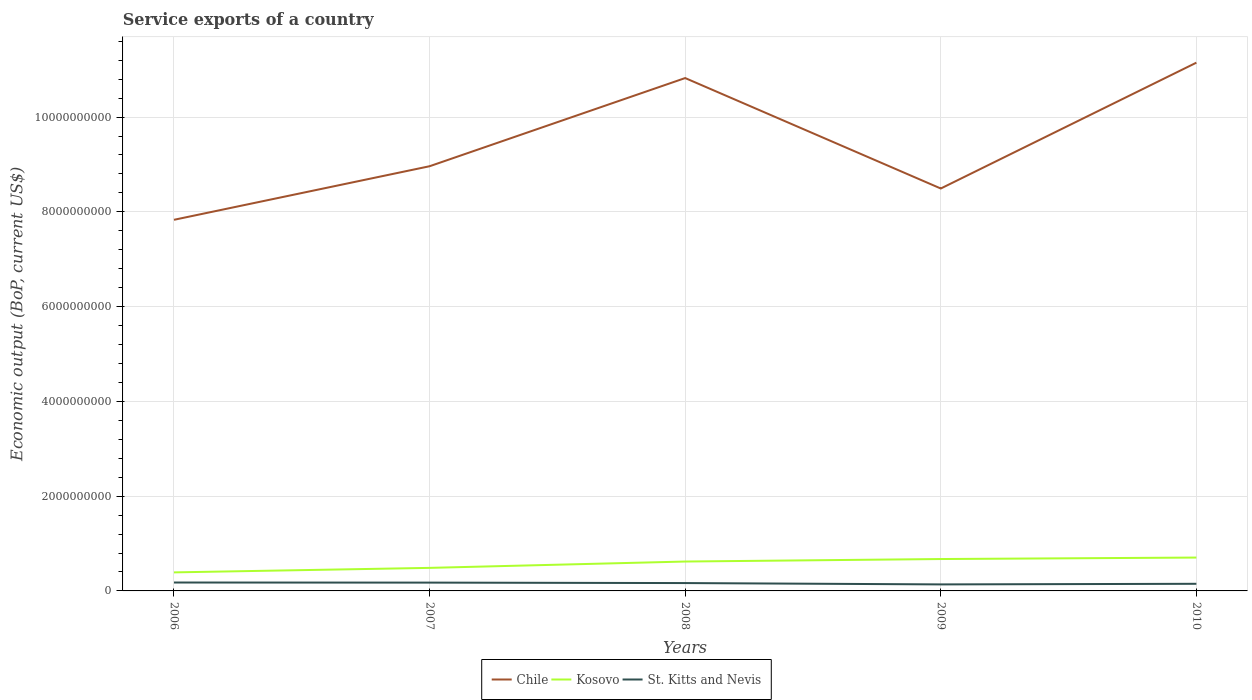Does the line corresponding to St. Kitts and Nevis intersect with the line corresponding to Chile?
Ensure brevity in your answer.  No. Is the number of lines equal to the number of legend labels?
Your answer should be compact. Yes. Across all years, what is the maximum service exports in St. Kitts and Nevis?
Make the answer very short. 1.37e+08. What is the total service exports in Kosovo in the graph?
Offer a terse response. -1.34e+08. What is the difference between the highest and the second highest service exports in Kosovo?
Keep it short and to the point. 3.13e+08. What is the difference between two consecutive major ticks on the Y-axis?
Your answer should be compact. 2.00e+09. Does the graph contain any zero values?
Ensure brevity in your answer.  No. Does the graph contain grids?
Offer a terse response. Yes. Where does the legend appear in the graph?
Provide a short and direct response. Bottom center. What is the title of the graph?
Provide a short and direct response. Service exports of a country. Does "Sweden" appear as one of the legend labels in the graph?
Your response must be concise. No. What is the label or title of the Y-axis?
Offer a terse response. Economic output (BoP, current US$). What is the Economic output (BoP, current US$) in Chile in 2006?
Make the answer very short. 7.83e+09. What is the Economic output (BoP, current US$) of Kosovo in 2006?
Offer a very short reply. 3.91e+08. What is the Economic output (BoP, current US$) in St. Kitts and Nevis in 2006?
Your response must be concise. 1.77e+08. What is the Economic output (BoP, current US$) of Chile in 2007?
Provide a succinct answer. 8.96e+09. What is the Economic output (BoP, current US$) in Kosovo in 2007?
Provide a succinct answer. 4.86e+08. What is the Economic output (BoP, current US$) of St. Kitts and Nevis in 2007?
Ensure brevity in your answer.  1.75e+08. What is the Economic output (BoP, current US$) of Chile in 2008?
Offer a terse response. 1.08e+1. What is the Economic output (BoP, current US$) in Kosovo in 2008?
Your response must be concise. 6.20e+08. What is the Economic output (BoP, current US$) in St. Kitts and Nevis in 2008?
Offer a very short reply. 1.66e+08. What is the Economic output (BoP, current US$) of Chile in 2009?
Provide a succinct answer. 8.49e+09. What is the Economic output (BoP, current US$) in Kosovo in 2009?
Your response must be concise. 6.73e+08. What is the Economic output (BoP, current US$) in St. Kitts and Nevis in 2009?
Make the answer very short. 1.37e+08. What is the Economic output (BoP, current US$) in Chile in 2010?
Your answer should be compact. 1.11e+1. What is the Economic output (BoP, current US$) of Kosovo in 2010?
Provide a short and direct response. 7.04e+08. What is the Economic output (BoP, current US$) of St. Kitts and Nevis in 2010?
Your answer should be compact. 1.50e+08. Across all years, what is the maximum Economic output (BoP, current US$) in Chile?
Give a very brief answer. 1.11e+1. Across all years, what is the maximum Economic output (BoP, current US$) of Kosovo?
Offer a very short reply. 7.04e+08. Across all years, what is the maximum Economic output (BoP, current US$) in St. Kitts and Nevis?
Your answer should be compact. 1.77e+08. Across all years, what is the minimum Economic output (BoP, current US$) in Chile?
Ensure brevity in your answer.  7.83e+09. Across all years, what is the minimum Economic output (BoP, current US$) of Kosovo?
Provide a succinct answer. 3.91e+08. Across all years, what is the minimum Economic output (BoP, current US$) in St. Kitts and Nevis?
Your answer should be very brief. 1.37e+08. What is the total Economic output (BoP, current US$) in Chile in the graph?
Keep it short and to the point. 4.73e+1. What is the total Economic output (BoP, current US$) of Kosovo in the graph?
Provide a succinct answer. 2.87e+09. What is the total Economic output (BoP, current US$) in St. Kitts and Nevis in the graph?
Your answer should be very brief. 8.06e+08. What is the difference between the Economic output (BoP, current US$) of Chile in 2006 and that in 2007?
Make the answer very short. -1.13e+09. What is the difference between the Economic output (BoP, current US$) of Kosovo in 2006 and that in 2007?
Your answer should be compact. -9.52e+07. What is the difference between the Economic output (BoP, current US$) in St. Kitts and Nevis in 2006 and that in 2007?
Your answer should be compact. 2.00e+06. What is the difference between the Economic output (BoP, current US$) of Chile in 2006 and that in 2008?
Provide a succinct answer. -2.99e+09. What is the difference between the Economic output (BoP, current US$) of Kosovo in 2006 and that in 2008?
Provide a succinct answer. -2.29e+08. What is the difference between the Economic output (BoP, current US$) of St. Kitts and Nevis in 2006 and that in 2008?
Your response must be concise. 1.17e+07. What is the difference between the Economic output (BoP, current US$) of Chile in 2006 and that in 2009?
Your answer should be compact. -6.61e+08. What is the difference between the Economic output (BoP, current US$) in Kosovo in 2006 and that in 2009?
Your answer should be very brief. -2.82e+08. What is the difference between the Economic output (BoP, current US$) in St. Kitts and Nevis in 2006 and that in 2009?
Offer a terse response. 4.02e+07. What is the difference between the Economic output (BoP, current US$) in Chile in 2006 and that in 2010?
Offer a very short reply. -3.32e+09. What is the difference between the Economic output (BoP, current US$) of Kosovo in 2006 and that in 2010?
Provide a succinct answer. -3.13e+08. What is the difference between the Economic output (BoP, current US$) in St. Kitts and Nevis in 2006 and that in 2010?
Ensure brevity in your answer.  2.73e+07. What is the difference between the Economic output (BoP, current US$) in Chile in 2007 and that in 2008?
Provide a succinct answer. -1.86e+09. What is the difference between the Economic output (BoP, current US$) in Kosovo in 2007 and that in 2008?
Ensure brevity in your answer.  -1.34e+08. What is the difference between the Economic output (BoP, current US$) in St. Kitts and Nevis in 2007 and that in 2008?
Your answer should be compact. 9.67e+06. What is the difference between the Economic output (BoP, current US$) in Chile in 2007 and that in 2009?
Your answer should be very brief. 4.70e+08. What is the difference between the Economic output (BoP, current US$) of Kosovo in 2007 and that in 2009?
Keep it short and to the point. -1.87e+08. What is the difference between the Economic output (BoP, current US$) of St. Kitts and Nevis in 2007 and that in 2009?
Offer a very short reply. 3.82e+07. What is the difference between the Economic output (BoP, current US$) of Chile in 2007 and that in 2010?
Ensure brevity in your answer.  -2.19e+09. What is the difference between the Economic output (BoP, current US$) of Kosovo in 2007 and that in 2010?
Provide a short and direct response. -2.17e+08. What is the difference between the Economic output (BoP, current US$) of St. Kitts and Nevis in 2007 and that in 2010?
Ensure brevity in your answer.  2.53e+07. What is the difference between the Economic output (BoP, current US$) of Chile in 2008 and that in 2009?
Make the answer very short. 2.33e+09. What is the difference between the Economic output (BoP, current US$) of Kosovo in 2008 and that in 2009?
Make the answer very short. -5.27e+07. What is the difference between the Economic output (BoP, current US$) of St. Kitts and Nevis in 2008 and that in 2009?
Your answer should be compact. 2.85e+07. What is the difference between the Economic output (BoP, current US$) in Chile in 2008 and that in 2010?
Give a very brief answer. -3.25e+08. What is the difference between the Economic output (BoP, current US$) of Kosovo in 2008 and that in 2010?
Your answer should be very brief. -8.37e+07. What is the difference between the Economic output (BoP, current US$) in St. Kitts and Nevis in 2008 and that in 2010?
Ensure brevity in your answer.  1.56e+07. What is the difference between the Economic output (BoP, current US$) of Chile in 2009 and that in 2010?
Your answer should be very brief. -2.66e+09. What is the difference between the Economic output (BoP, current US$) of Kosovo in 2009 and that in 2010?
Your response must be concise. -3.09e+07. What is the difference between the Economic output (BoP, current US$) of St. Kitts and Nevis in 2009 and that in 2010?
Give a very brief answer. -1.29e+07. What is the difference between the Economic output (BoP, current US$) of Chile in 2006 and the Economic output (BoP, current US$) of Kosovo in 2007?
Ensure brevity in your answer.  7.35e+09. What is the difference between the Economic output (BoP, current US$) in Chile in 2006 and the Economic output (BoP, current US$) in St. Kitts and Nevis in 2007?
Your answer should be compact. 7.66e+09. What is the difference between the Economic output (BoP, current US$) in Kosovo in 2006 and the Economic output (BoP, current US$) in St. Kitts and Nevis in 2007?
Keep it short and to the point. 2.16e+08. What is the difference between the Economic output (BoP, current US$) in Chile in 2006 and the Economic output (BoP, current US$) in Kosovo in 2008?
Offer a very short reply. 7.21e+09. What is the difference between the Economic output (BoP, current US$) in Chile in 2006 and the Economic output (BoP, current US$) in St. Kitts and Nevis in 2008?
Provide a succinct answer. 7.67e+09. What is the difference between the Economic output (BoP, current US$) in Kosovo in 2006 and the Economic output (BoP, current US$) in St. Kitts and Nevis in 2008?
Provide a succinct answer. 2.25e+08. What is the difference between the Economic output (BoP, current US$) of Chile in 2006 and the Economic output (BoP, current US$) of Kosovo in 2009?
Offer a very short reply. 7.16e+09. What is the difference between the Economic output (BoP, current US$) in Chile in 2006 and the Economic output (BoP, current US$) in St. Kitts and Nevis in 2009?
Make the answer very short. 7.69e+09. What is the difference between the Economic output (BoP, current US$) of Kosovo in 2006 and the Economic output (BoP, current US$) of St. Kitts and Nevis in 2009?
Provide a short and direct response. 2.54e+08. What is the difference between the Economic output (BoP, current US$) of Chile in 2006 and the Economic output (BoP, current US$) of Kosovo in 2010?
Provide a succinct answer. 7.13e+09. What is the difference between the Economic output (BoP, current US$) in Chile in 2006 and the Economic output (BoP, current US$) in St. Kitts and Nevis in 2010?
Provide a short and direct response. 7.68e+09. What is the difference between the Economic output (BoP, current US$) in Kosovo in 2006 and the Economic output (BoP, current US$) in St. Kitts and Nevis in 2010?
Make the answer very short. 2.41e+08. What is the difference between the Economic output (BoP, current US$) of Chile in 2007 and the Economic output (BoP, current US$) of Kosovo in 2008?
Ensure brevity in your answer.  8.34e+09. What is the difference between the Economic output (BoP, current US$) in Chile in 2007 and the Economic output (BoP, current US$) in St. Kitts and Nevis in 2008?
Your answer should be very brief. 8.80e+09. What is the difference between the Economic output (BoP, current US$) of Kosovo in 2007 and the Economic output (BoP, current US$) of St. Kitts and Nevis in 2008?
Offer a terse response. 3.21e+08. What is the difference between the Economic output (BoP, current US$) of Chile in 2007 and the Economic output (BoP, current US$) of Kosovo in 2009?
Keep it short and to the point. 8.29e+09. What is the difference between the Economic output (BoP, current US$) in Chile in 2007 and the Economic output (BoP, current US$) in St. Kitts and Nevis in 2009?
Offer a very short reply. 8.83e+09. What is the difference between the Economic output (BoP, current US$) of Kosovo in 2007 and the Economic output (BoP, current US$) of St. Kitts and Nevis in 2009?
Ensure brevity in your answer.  3.49e+08. What is the difference between the Economic output (BoP, current US$) of Chile in 2007 and the Economic output (BoP, current US$) of Kosovo in 2010?
Make the answer very short. 8.26e+09. What is the difference between the Economic output (BoP, current US$) in Chile in 2007 and the Economic output (BoP, current US$) in St. Kitts and Nevis in 2010?
Provide a succinct answer. 8.81e+09. What is the difference between the Economic output (BoP, current US$) of Kosovo in 2007 and the Economic output (BoP, current US$) of St. Kitts and Nevis in 2010?
Ensure brevity in your answer.  3.36e+08. What is the difference between the Economic output (BoP, current US$) of Chile in 2008 and the Economic output (BoP, current US$) of Kosovo in 2009?
Your answer should be very brief. 1.02e+1. What is the difference between the Economic output (BoP, current US$) of Chile in 2008 and the Economic output (BoP, current US$) of St. Kitts and Nevis in 2009?
Make the answer very short. 1.07e+1. What is the difference between the Economic output (BoP, current US$) of Kosovo in 2008 and the Economic output (BoP, current US$) of St. Kitts and Nevis in 2009?
Offer a terse response. 4.83e+08. What is the difference between the Economic output (BoP, current US$) of Chile in 2008 and the Economic output (BoP, current US$) of Kosovo in 2010?
Your response must be concise. 1.01e+1. What is the difference between the Economic output (BoP, current US$) in Chile in 2008 and the Economic output (BoP, current US$) in St. Kitts and Nevis in 2010?
Provide a short and direct response. 1.07e+1. What is the difference between the Economic output (BoP, current US$) of Kosovo in 2008 and the Economic output (BoP, current US$) of St. Kitts and Nevis in 2010?
Provide a succinct answer. 4.70e+08. What is the difference between the Economic output (BoP, current US$) of Chile in 2009 and the Economic output (BoP, current US$) of Kosovo in 2010?
Keep it short and to the point. 7.79e+09. What is the difference between the Economic output (BoP, current US$) of Chile in 2009 and the Economic output (BoP, current US$) of St. Kitts and Nevis in 2010?
Your answer should be very brief. 8.34e+09. What is the difference between the Economic output (BoP, current US$) in Kosovo in 2009 and the Economic output (BoP, current US$) in St. Kitts and Nevis in 2010?
Provide a short and direct response. 5.23e+08. What is the average Economic output (BoP, current US$) in Chile per year?
Provide a succinct answer. 9.45e+09. What is the average Economic output (BoP, current US$) in Kosovo per year?
Offer a very short reply. 5.75e+08. What is the average Economic output (BoP, current US$) in St. Kitts and Nevis per year?
Offer a terse response. 1.61e+08. In the year 2006, what is the difference between the Economic output (BoP, current US$) in Chile and Economic output (BoP, current US$) in Kosovo?
Ensure brevity in your answer.  7.44e+09. In the year 2006, what is the difference between the Economic output (BoP, current US$) of Chile and Economic output (BoP, current US$) of St. Kitts and Nevis?
Make the answer very short. 7.65e+09. In the year 2006, what is the difference between the Economic output (BoP, current US$) of Kosovo and Economic output (BoP, current US$) of St. Kitts and Nevis?
Your response must be concise. 2.14e+08. In the year 2007, what is the difference between the Economic output (BoP, current US$) in Chile and Economic output (BoP, current US$) in Kosovo?
Your answer should be compact. 8.48e+09. In the year 2007, what is the difference between the Economic output (BoP, current US$) of Chile and Economic output (BoP, current US$) of St. Kitts and Nevis?
Provide a succinct answer. 8.79e+09. In the year 2007, what is the difference between the Economic output (BoP, current US$) in Kosovo and Economic output (BoP, current US$) in St. Kitts and Nevis?
Your response must be concise. 3.11e+08. In the year 2008, what is the difference between the Economic output (BoP, current US$) in Chile and Economic output (BoP, current US$) in Kosovo?
Provide a succinct answer. 1.02e+1. In the year 2008, what is the difference between the Economic output (BoP, current US$) in Chile and Economic output (BoP, current US$) in St. Kitts and Nevis?
Provide a succinct answer. 1.07e+1. In the year 2008, what is the difference between the Economic output (BoP, current US$) in Kosovo and Economic output (BoP, current US$) in St. Kitts and Nevis?
Provide a succinct answer. 4.54e+08. In the year 2009, what is the difference between the Economic output (BoP, current US$) in Chile and Economic output (BoP, current US$) in Kosovo?
Offer a terse response. 7.82e+09. In the year 2009, what is the difference between the Economic output (BoP, current US$) in Chile and Economic output (BoP, current US$) in St. Kitts and Nevis?
Provide a succinct answer. 8.36e+09. In the year 2009, what is the difference between the Economic output (BoP, current US$) of Kosovo and Economic output (BoP, current US$) of St. Kitts and Nevis?
Provide a succinct answer. 5.36e+08. In the year 2010, what is the difference between the Economic output (BoP, current US$) of Chile and Economic output (BoP, current US$) of Kosovo?
Keep it short and to the point. 1.04e+1. In the year 2010, what is the difference between the Economic output (BoP, current US$) in Chile and Economic output (BoP, current US$) in St. Kitts and Nevis?
Give a very brief answer. 1.10e+1. In the year 2010, what is the difference between the Economic output (BoP, current US$) of Kosovo and Economic output (BoP, current US$) of St. Kitts and Nevis?
Provide a short and direct response. 5.54e+08. What is the ratio of the Economic output (BoP, current US$) in Chile in 2006 to that in 2007?
Your answer should be very brief. 0.87. What is the ratio of the Economic output (BoP, current US$) of Kosovo in 2006 to that in 2007?
Provide a succinct answer. 0.8. What is the ratio of the Economic output (BoP, current US$) in St. Kitts and Nevis in 2006 to that in 2007?
Your answer should be very brief. 1.01. What is the ratio of the Economic output (BoP, current US$) in Chile in 2006 to that in 2008?
Your answer should be compact. 0.72. What is the ratio of the Economic output (BoP, current US$) of Kosovo in 2006 to that in 2008?
Make the answer very short. 0.63. What is the ratio of the Economic output (BoP, current US$) in St. Kitts and Nevis in 2006 to that in 2008?
Give a very brief answer. 1.07. What is the ratio of the Economic output (BoP, current US$) in Chile in 2006 to that in 2009?
Make the answer very short. 0.92. What is the ratio of the Economic output (BoP, current US$) of Kosovo in 2006 to that in 2009?
Offer a terse response. 0.58. What is the ratio of the Economic output (BoP, current US$) in St. Kitts and Nevis in 2006 to that in 2009?
Provide a short and direct response. 1.29. What is the ratio of the Economic output (BoP, current US$) in Chile in 2006 to that in 2010?
Give a very brief answer. 0.7. What is the ratio of the Economic output (BoP, current US$) in Kosovo in 2006 to that in 2010?
Make the answer very short. 0.56. What is the ratio of the Economic output (BoP, current US$) in St. Kitts and Nevis in 2006 to that in 2010?
Ensure brevity in your answer.  1.18. What is the ratio of the Economic output (BoP, current US$) in Chile in 2007 to that in 2008?
Your response must be concise. 0.83. What is the ratio of the Economic output (BoP, current US$) of Kosovo in 2007 to that in 2008?
Your answer should be very brief. 0.78. What is the ratio of the Economic output (BoP, current US$) of St. Kitts and Nevis in 2007 to that in 2008?
Your answer should be compact. 1.06. What is the ratio of the Economic output (BoP, current US$) of Chile in 2007 to that in 2009?
Your response must be concise. 1.06. What is the ratio of the Economic output (BoP, current US$) of Kosovo in 2007 to that in 2009?
Offer a terse response. 0.72. What is the ratio of the Economic output (BoP, current US$) in St. Kitts and Nevis in 2007 to that in 2009?
Provide a short and direct response. 1.28. What is the ratio of the Economic output (BoP, current US$) in Chile in 2007 to that in 2010?
Offer a terse response. 0.8. What is the ratio of the Economic output (BoP, current US$) in Kosovo in 2007 to that in 2010?
Offer a very short reply. 0.69. What is the ratio of the Economic output (BoP, current US$) in St. Kitts and Nevis in 2007 to that in 2010?
Make the answer very short. 1.17. What is the ratio of the Economic output (BoP, current US$) in Chile in 2008 to that in 2009?
Make the answer very short. 1.27. What is the ratio of the Economic output (BoP, current US$) in Kosovo in 2008 to that in 2009?
Your answer should be compact. 0.92. What is the ratio of the Economic output (BoP, current US$) in St. Kitts and Nevis in 2008 to that in 2009?
Your answer should be compact. 1.21. What is the ratio of the Economic output (BoP, current US$) of Chile in 2008 to that in 2010?
Your answer should be very brief. 0.97. What is the ratio of the Economic output (BoP, current US$) of Kosovo in 2008 to that in 2010?
Make the answer very short. 0.88. What is the ratio of the Economic output (BoP, current US$) in St. Kitts and Nevis in 2008 to that in 2010?
Ensure brevity in your answer.  1.1. What is the ratio of the Economic output (BoP, current US$) of Chile in 2009 to that in 2010?
Give a very brief answer. 0.76. What is the ratio of the Economic output (BoP, current US$) in Kosovo in 2009 to that in 2010?
Keep it short and to the point. 0.96. What is the ratio of the Economic output (BoP, current US$) in St. Kitts and Nevis in 2009 to that in 2010?
Provide a short and direct response. 0.91. What is the difference between the highest and the second highest Economic output (BoP, current US$) of Chile?
Ensure brevity in your answer.  3.25e+08. What is the difference between the highest and the second highest Economic output (BoP, current US$) of Kosovo?
Your answer should be compact. 3.09e+07. What is the difference between the highest and the second highest Economic output (BoP, current US$) in St. Kitts and Nevis?
Provide a succinct answer. 2.00e+06. What is the difference between the highest and the lowest Economic output (BoP, current US$) of Chile?
Your response must be concise. 3.32e+09. What is the difference between the highest and the lowest Economic output (BoP, current US$) in Kosovo?
Offer a very short reply. 3.13e+08. What is the difference between the highest and the lowest Economic output (BoP, current US$) of St. Kitts and Nevis?
Your answer should be very brief. 4.02e+07. 